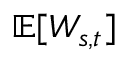<formula> <loc_0><loc_0><loc_500><loc_500>\mathbb { E } [ W _ { s , t } ]</formula> 